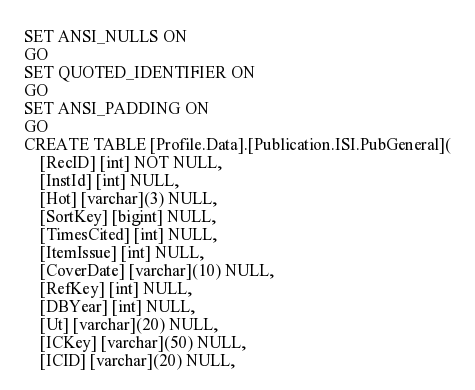<code> <loc_0><loc_0><loc_500><loc_500><_SQL_>SET ANSI_NULLS ON
GO
SET QUOTED_IDENTIFIER ON
GO
SET ANSI_PADDING ON
GO
CREATE TABLE [Profile.Data].[Publication.ISI.PubGeneral](
	[RecID] [int] NOT NULL,
	[InstId] [int] NULL,
	[Hot] [varchar](3) NULL,
	[SortKey] [bigint] NULL,
	[TimesCited] [int] NULL,
	[ItemIssue] [int] NULL,
	[CoverDate] [varchar](10) NULL,
	[RefKey] [int] NULL,
	[DBYear] [int] NULL,
	[Ut] [varchar](20) NULL,
	[ICKey] [varchar](50) NULL,
	[ICID] [varchar](20) NULL,</code> 